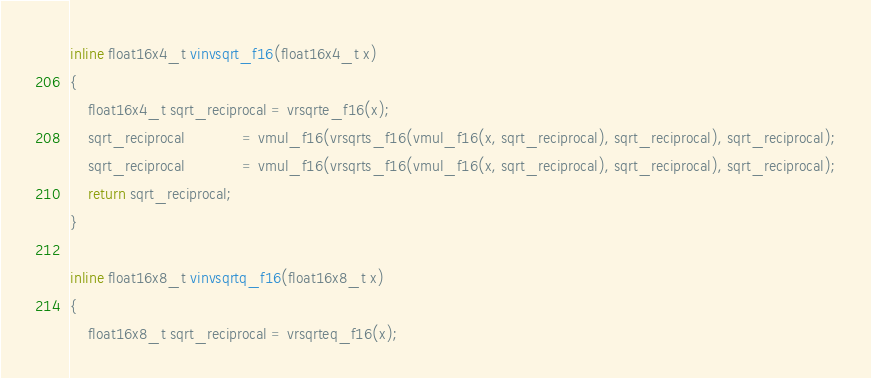<code> <loc_0><loc_0><loc_500><loc_500><_C++_>
inline float16x4_t vinvsqrt_f16(float16x4_t x)
{
    float16x4_t sqrt_reciprocal = vrsqrte_f16(x);
    sqrt_reciprocal             = vmul_f16(vrsqrts_f16(vmul_f16(x, sqrt_reciprocal), sqrt_reciprocal), sqrt_reciprocal);
    sqrt_reciprocal             = vmul_f16(vrsqrts_f16(vmul_f16(x, sqrt_reciprocal), sqrt_reciprocal), sqrt_reciprocal);
    return sqrt_reciprocal;
}

inline float16x8_t vinvsqrtq_f16(float16x8_t x)
{
    float16x8_t sqrt_reciprocal = vrsqrteq_f16(x);</code> 